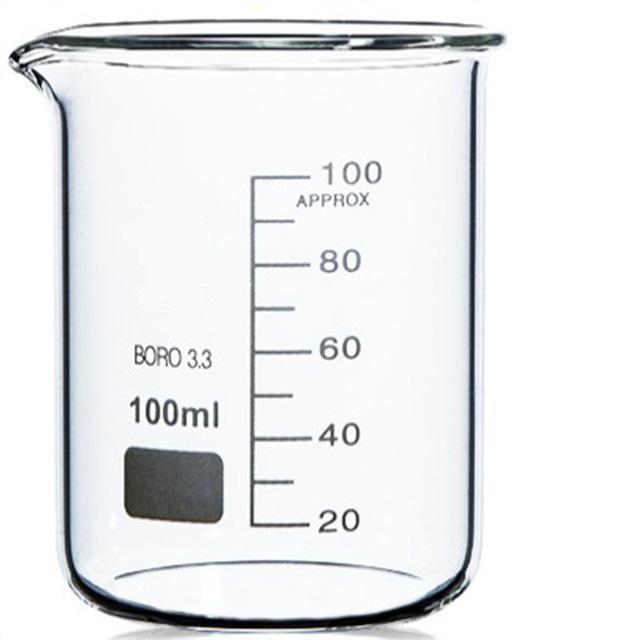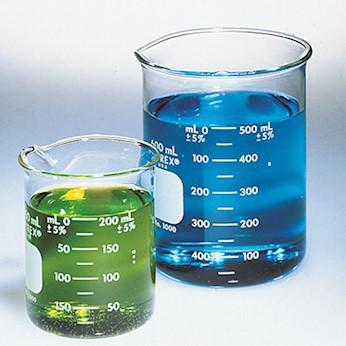The first image is the image on the left, the second image is the image on the right. For the images shown, is this caption "The right image includes a cylindrical container of blue liquid, and the left image features exactly one container." true? Answer yes or no. Yes. The first image is the image on the left, the second image is the image on the right. For the images shown, is this caption "The left and right image contains the same number of beakers." true? Answer yes or no. No. 